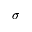<formula> <loc_0><loc_0><loc_500><loc_500>\sigma</formula> 